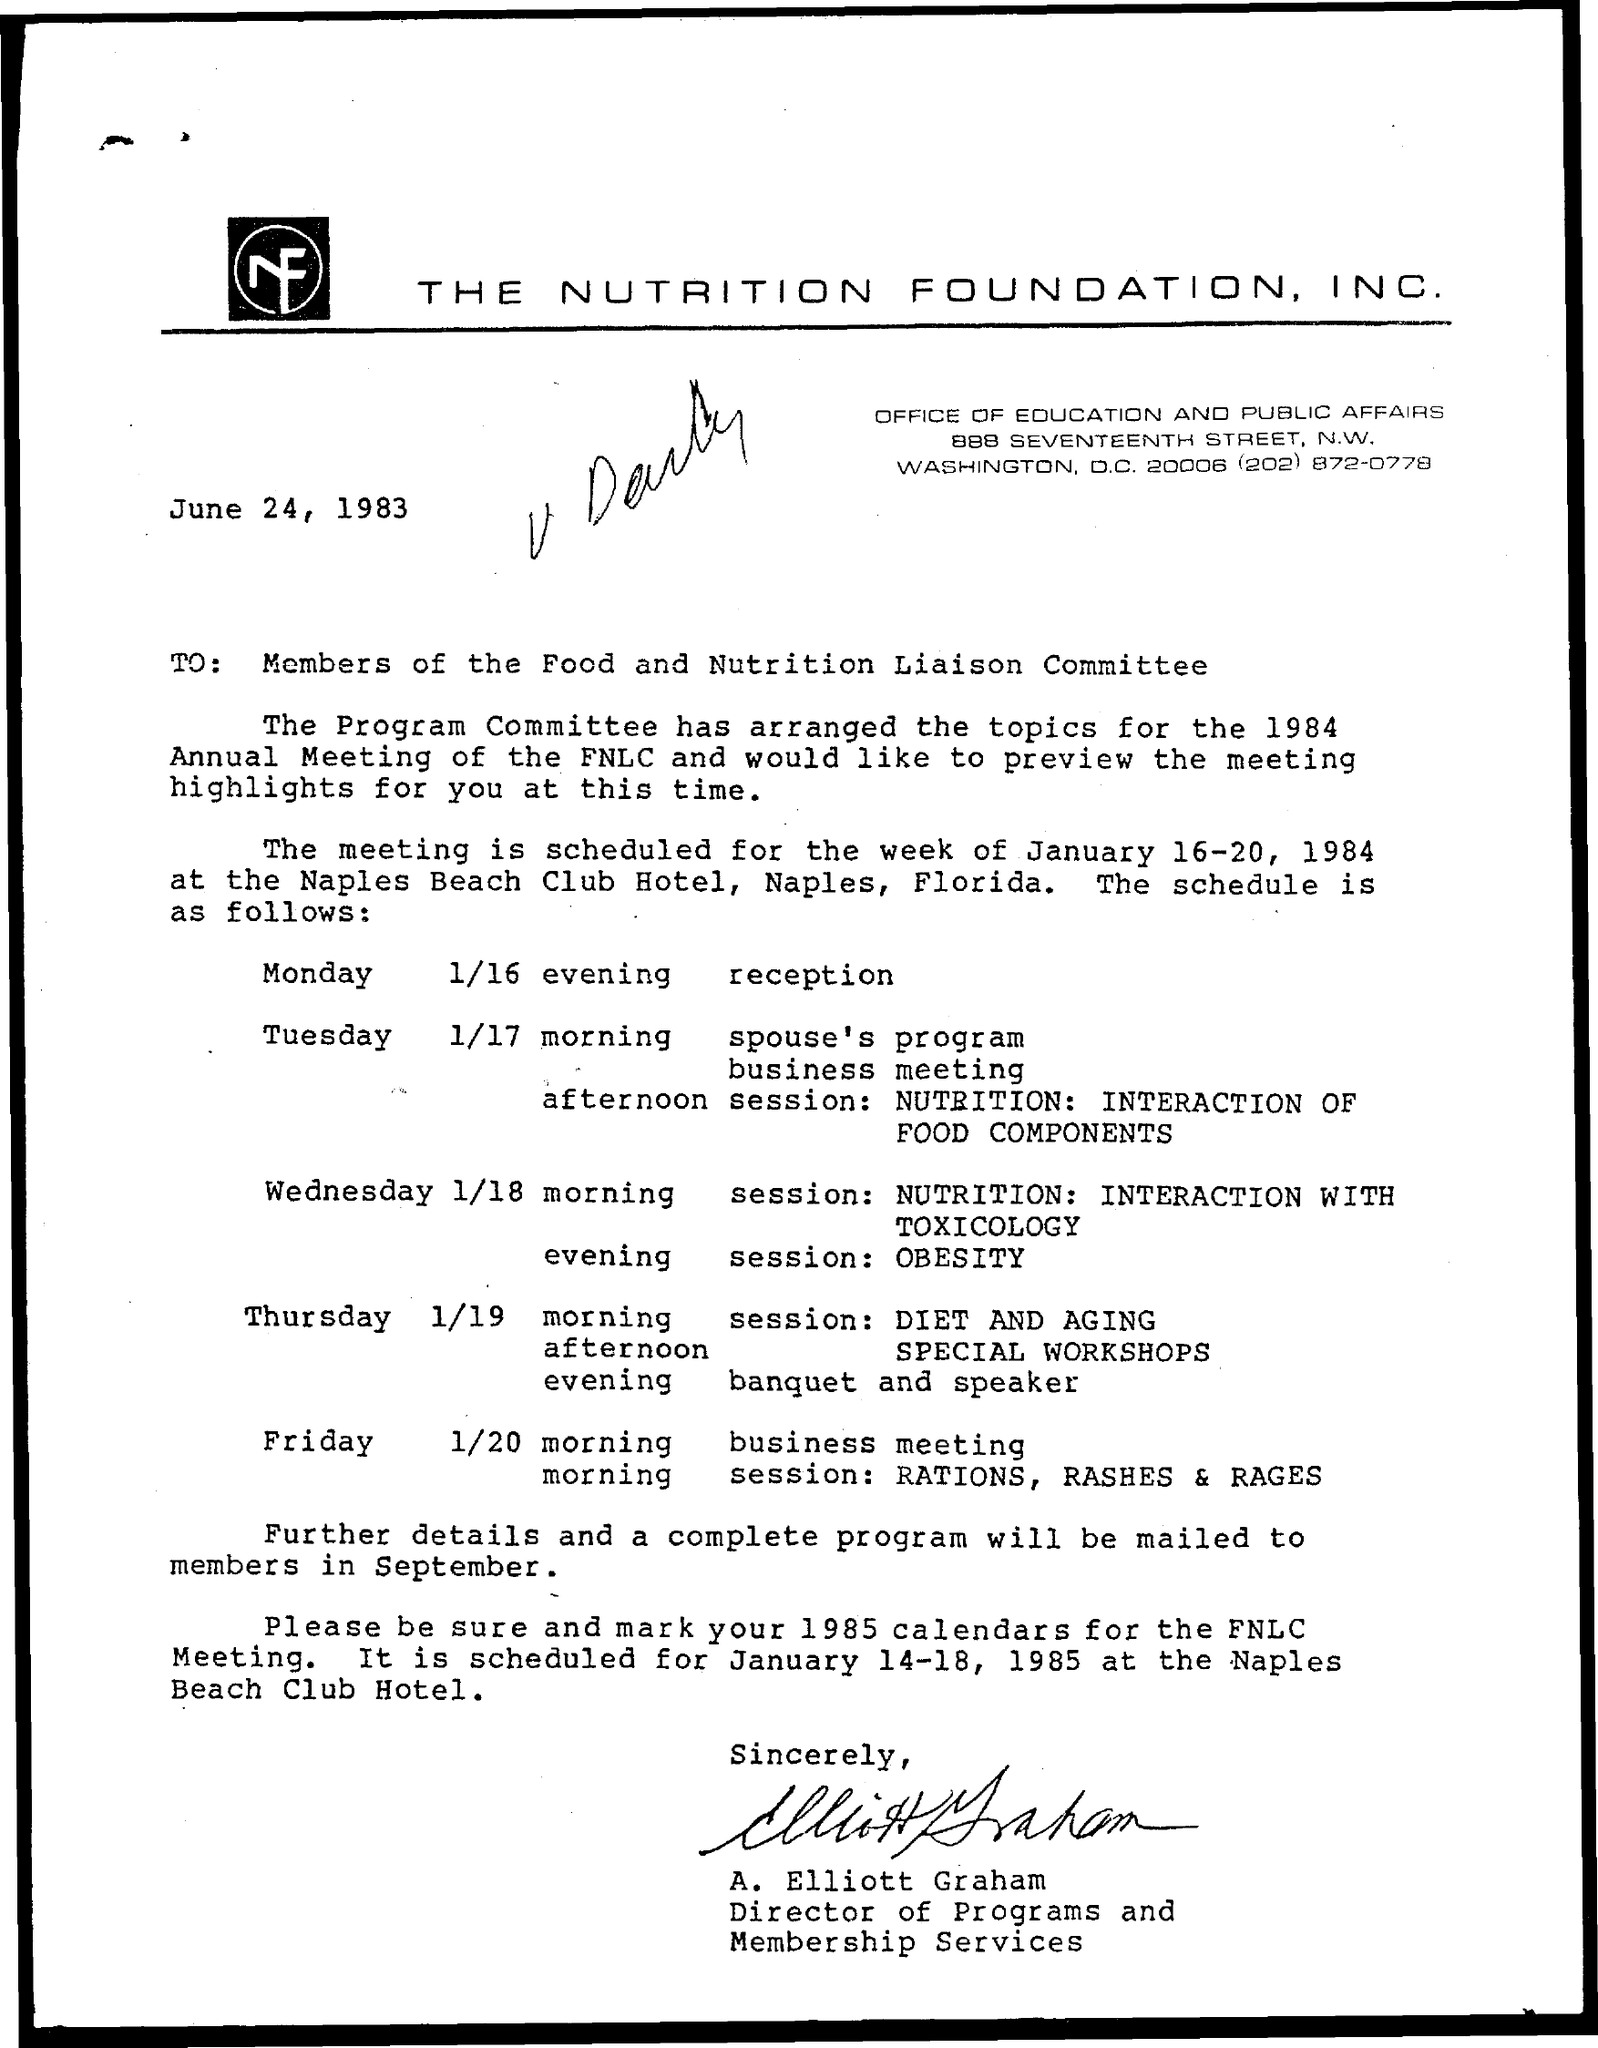What is the date mentioned ?
Give a very brief answer. June 24, 1983. What is the name of the morning session on thursday ?
Ensure brevity in your answer.  Diet and aging. What is the name of evening session on wednesday ?
Offer a very short reply. Obesity. 